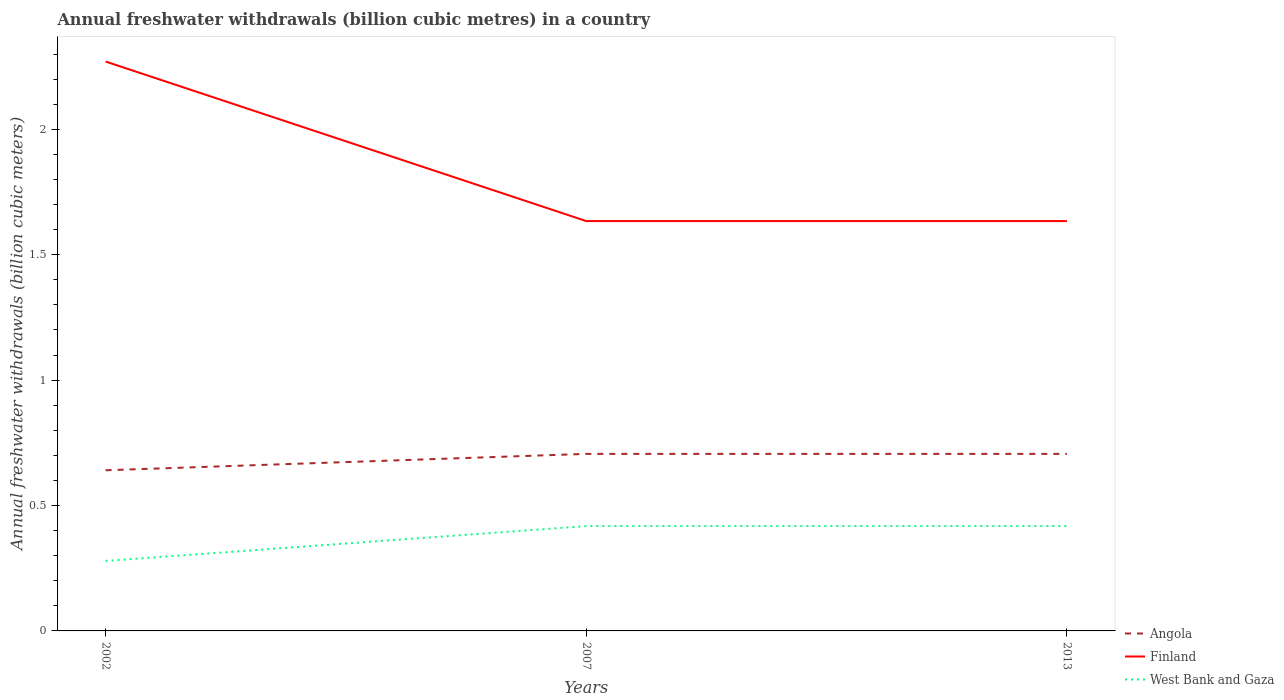How many different coloured lines are there?
Your answer should be very brief. 3. Is the number of lines equal to the number of legend labels?
Provide a succinct answer. Yes. Across all years, what is the maximum annual freshwater withdrawals in West Bank and Gaza?
Make the answer very short. 0.28. What is the total annual freshwater withdrawals in Finland in the graph?
Your answer should be compact. 0. What is the difference between the highest and the second highest annual freshwater withdrawals in Angola?
Give a very brief answer. 0.07. What is the difference between the highest and the lowest annual freshwater withdrawals in West Bank and Gaza?
Your answer should be very brief. 2. Is the annual freshwater withdrawals in Finland strictly greater than the annual freshwater withdrawals in Angola over the years?
Offer a terse response. No. How many years are there in the graph?
Your answer should be compact. 3. What is the difference between two consecutive major ticks on the Y-axis?
Provide a succinct answer. 0.5. Does the graph contain any zero values?
Offer a terse response. No. What is the title of the graph?
Make the answer very short. Annual freshwater withdrawals (billion cubic metres) in a country. What is the label or title of the X-axis?
Give a very brief answer. Years. What is the label or title of the Y-axis?
Your answer should be compact. Annual freshwater withdrawals (billion cubic meters). What is the Annual freshwater withdrawals (billion cubic meters) in Angola in 2002?
Provide a succinct answer. 0.64. What is the Annual freshwater withdrawals (billion cubic meters) in Finland in 2002?
Your answer should be compact. 2.27. What is the Annual freshwater withdrawals (billion cubic meters) in West Bank and Gaza in 2002?
Ensure brevity in your answer.  0.28. What is the Annual freshwater withdrawals (billion cubic meters) in Angola in 2007?
Provide a short and direct response. 0.71. What is the Annual freshwater withdrawals (billion cubic meters) in Finland in 2007?
Your answer should be very brief. 1.63. What is the Annual freshwater withdrawals (billion cubic meters) in West Bank and Gaza in 2007?
Make the answer very short. 0.42. What is the Annual freshwater withdrawals (billion cubic meters) in Angola in 2013?
Your answer should be very brief. 0.71. What is the Annual freshwater withdrawals (billion cubic meters) in Finland in 2013?
Ensure brevity in your answer.  1.63. What is the Annual freshwater withdrawals (billion cubic meters) in West Bank and Gaza in 2013?
Keep it short and to the point. 0.42. Across all years, what is the maximum Annual freshwater withdrawals (billion cubic meters) of Angola?
Keep it short and to the point. 0.71. Across all years, what is the maximum Annual freshwater withdrawals (billion cubic meters) of Finland?
Make the answer very short. 2.27. Across all years, what is the maximum Annual freshwater withdrawals (billion cubic meters) in West Bank and Gaza?
Make the answer very short. 0.42. Across all years, what is the minimum Annual freshwater withdrawals (billion cubic meters) in Angola?
Give a very brief answer. 0.64. Across all years, what is the minimum Annual freshwater withdrawals (billion cubic meters) of Finland?
Keep it short and to the point. 1.63. Across all years, what is the minimum Annual freshwater withdrawals (billion cubic meters) in West Bank and Gaza?
Offer a terse response. 0.28. What is the total Annual freshwater withdrawals (billion cubic meters) in Angola in the graph?
Offer a terse response. 2.05. What is the total Annual freshwater withdrawals (billion cubic meters) in Finland in the graph?
Ensure brevity in your answer.  5.54. What is the total Annual freshwater withdrawals (billion cubic meters) in West Bank and Gaza in the graph?
Give a very brief answer. 1.11. What is the difference between the Annual freshwater withdrawals (billion cubic meters) of Angola in 2002 and that in 2007?
Your answer should be compact. -0.07. What is the difference between the Annual freshwater withdrawals (billion cubic meters) of Finland in 2002 and that in 2007?
Offer a terse response. 0.64. What is the difference between the Annual freshwater withdrawals (billion cubic meters) in West Bank and Gaza in 2002 and that in 2007?
Ensure brevity in your answer.  -0.14. What is the difference between the Annual freshwater withdrawals (billion cubic meters) in Angola in 2002 and that in 2013?
Your response must be concise. -0.07. What is the difference between the Annual freshwater withdrawals (billion cubic meters) of Finland in 2002 and that in 2013?
Your answer should be very brief. 0.64. What is the difference between the Annual freshwater withdrawals (billion cubic meters) of West Bank and Gaza in 2002 and that in 2013?
Your response must be concise. -0.14. What is the difference between the Annual freshwater withdrawals (billion cubic meters) in Finland in 2007 and that in 2013?
Ensure brevity in your answer.  0. What is the difference between the Annual freshwater withdrawals (billion cubic meters) of Angola in 2002 and the Annual freshwater withdrawals (billion cubic meters) of Finland in 2007?
Offer a very short reply. -0.99. What is the difference between the Annual freshwater withdrawals (billion cubic meters) of Angola in 2002 and the Annual freshwater withdrawals (billion cubic meters) of West Bank and Gaza in 2007?
Provide a short and direct response. 0.22. What is the difference between the Annual freshwater withdrawals (billion cubic meters) of Finland in 2002 and the Annual freshwater withdrawals (billion cubic meters) of West Bank and Gaza in 2007?
Provide a short and direct response. 1.85. What is the difference between the Annual freshwater withdrawals (billion cubic meters) of Angola in 2002 and the Annual freshwater withdrawals (billion cubic meters) of Finland in 2013?
Provide a succinct answer. -0.99. What is the difference between the Annual freshwater withdrawals (billion cubic meters) in Angola in 2002 and the Annual freshwater withdrawals (billion cubic meters) in West Bank and Gaza in 2013?
Provide a succinct answer. 0.22. What is the difference between the Annual freshwater withdrawals (billion cubic meters) in Finland in 2002 and the Annual freshwater withdrawals (billion cubic meters) in West Bank and Gaza in 2013?
Give a very brief answer. 1.85. What is the difference between the Annual freshwater withdrawals (billion cubic meters) of Angola in 2007 and the Annual freshwater withdrawals (billion cubic meters) of Finland in 2013?
Ensure brevity in your answer.  -0.93. What is the difference between the Annual freshwater withdrawals (billion cubic meters) of Angola in 2007 and the Annual freshwater withdrawals (billion cubic meters) of West Bank and Gaza in 2013?
Your answer should be very brief. 0.29. What is the difference between the Annual freshwater withdrawals (billion cubic meters) in Finland in 2007 and the Annual freshwater withdrawals (billion cubic meters) in West Bank and Gaza in 2013?
Your answer should be compact. 1.22. What is the average Annual freshwater withdrawals (billion cubic meters) in Angola per year?
Provide a succinct answer. 0.68. What is the average Annual freshwater withdrawals (billion cubic meters) of Finland per year?
Make the answer very short. 1.85. What is the average Annual freshwater withdrawals (billion cubic meters) of West Bank and Gaza per year?
Provide a succinct answer. 0.37. In the year 2002, what is the difference between the Annual freshwater withdrawals (billion cubic meters) in Angola and Annual freshwater withdrawals (billion cubic meters) in Finland?
Your response must be concise. -1.63. In the year 2002, what is the difference between the Annual freshwater withdrawals (billion cubic meters) in Angola and Annual freshwater withdrawals (billion cubic meters) in West Bank and Gaza?
Provide a short and direct response. 0.36. In the year 2002, what is the difference between the Annual freshwater withdrawals (billion cubic meters) in Finland and Annual freshwater withdrawals (billion cubic meters) in West Bank and Gaza?
Your answer should be compact. 1.99. In the year 2007, what is the difference between the Annual freshwater withdrawals (billion cubic meters) of Angola and Annual freshwater withdrawals (billion cubic meters) of Finland?
Provide a short and direct response. -0.93. In the year 2007, what is the difference between the Annual freshwater withdrawals (billion cubic meters) of Angola and Annual freshwater withdrawals (billion cubic meters) of West Bank and Gaza?
Make the answer very short. 0.29. In the year 2007, what is the difference between the Annual freshwater withdrawals (billion cubic meters) in Finland and Annual freshwater withdrawals (billion cubic meters) in West Bank and Gaza?
Your response must be concise. 1.22. In the year 2013, what is the difference between the Annual freshwater withdrawals (billion cubic meters) of Angola and Annual freshwater withdrawals (billion cubic meters) of Finland?
Keep it short and to the point. -0.93. In the year 2013, what is the difference between the Annual freshwater withdrawals (billion cubic meters) in Angola and Annual freshwater withdrawals (billion cubic meters) in West Bank and Gaza?
Provide a short and direct response. 0.29. In the year 2013, what is the difference between the Annual freshwater withdrawals (billion cubic meters) of Finland and Annual freshwater withdrawals (billion cubic meters) of West Bank and Gaza?
Offer a very short reply. 1.22. What is the ratio of the Annual freshwater withdrawals (billion cubic meters) of Angola in 2002 to that in 2007?
Offer a very short reply. 0.91. What is the ratio of the Annual freshwater withdrawals (billion cubic meters) in Finland in 2002 to that in 2007?
Your answer should be compact. 1.39. What is the ratio of the Annual freshwater withdrawals (billion cubic meters) in West Bank and Gaza in 2002 to that in 2007?
Ensure brevity in your answer.  0.67. What is the ratio of the Annual freshwater withdrawals (billion cubic meters) of Angola in 2002 to that in 2013?
Make the answer very short. 0.91. What is the ratio of the Annual freshwater withdrawals (billion cubic meters) of Finland in 2002 to that in 2013?
Provide a succinct answer. 1.39. What is the ratio of the Annual freshwater withdrawals (billion cubic meters) in West Bank and Gaza in 2002 to that in 2013?
Your response must be concise. 0.67. What is the ratio of the Annual freshwater withdrawals (billion cubic meters) in Angola in 2007 to that in 2013?
Give a very brief answer. 1. What is the ratio of the Annual freshwater withdrawals (billion cubic meters) in West Bank and Gaza in 2007 to that in 2013?
Offer a very short reply. 1. What is the difference between the highest and the second highest Annual freshwater withdrawals (billion cubic meters) of Finland?
Give a very brief answer. 0.64. What is the difference between the highest and the second highest Annual freshwater withdrawals (billion cubic meters) in West Bank and Gaza?
Ensure brevity in your answer.  0. What is the difference between the highest and the lowest Annual freshwater withdrawals (billion cubic meters) in Angola?
Your answer should be compact. 0.07. What is the difference between the highest and the lowest Annual freshwater withdrawals (billion cubic meters) in Finland?
Your answer should be compact. 0.64. What is the difference between the highest and the lowest Annual freshwater withdrawals (billion cubic meters) in West Bank and Gaza?
Your answer should be very brief. 0.14. 